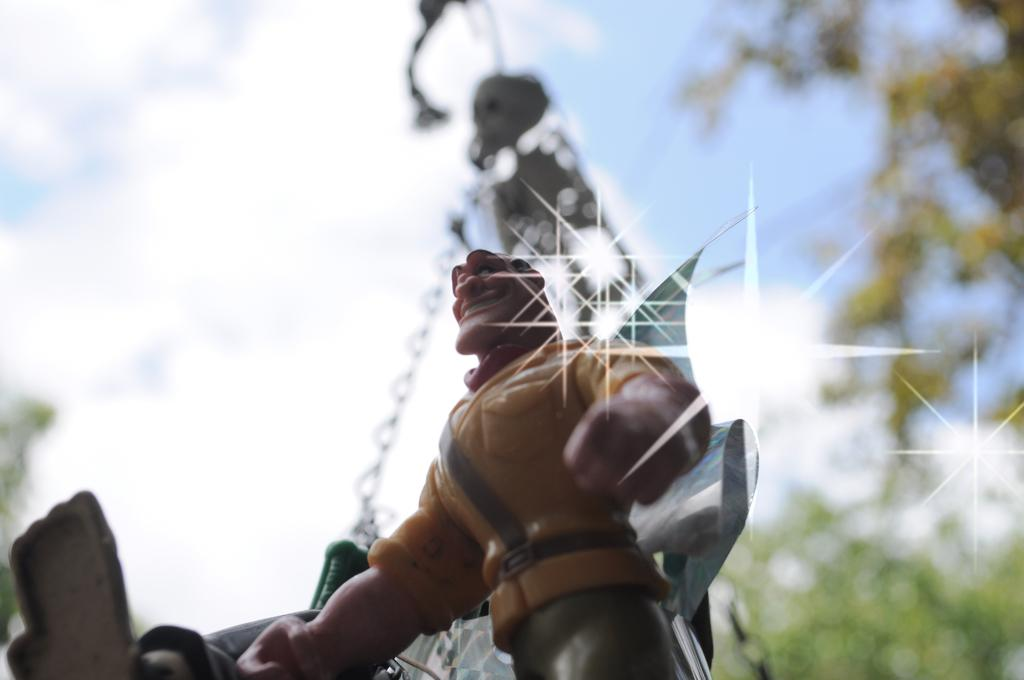What is the main object in the middle of the image? There is a toy in the middle of the image. What can be seen in the background of the image? There are trees in the background of the image. What is visible in the sky in the image? There are clouds in the sky, and the sky is blue. What type of oven is being used for the voyage in the image? There is no oven or voyage present in the image; it features a toy and a background with trees. 